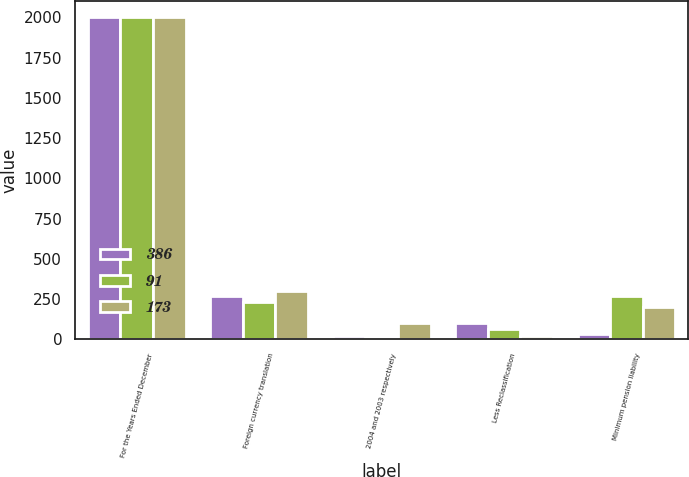<chart> <loc_0><loc_0><loc_500><loc_500><stacked_bar_chart><ecel><fcel>For the Years Ended December<fcel>Foreign currency translation<fcel>2004 and 2003 respectively<fcel>Less Reclassification<fcel>Minimum pension liability<nl><fcel>386<fcel>2005<fcel>271<fcel>18<fcel>103<fcel>30<nl><fcel>91<fcel>2004<fcel>234<fcel>8<fcel>66<fcel>266<nl><fcel>173<fcel>2003<fcel>302<fcel>98<fcel>22<fcel>201<nl></chart> 